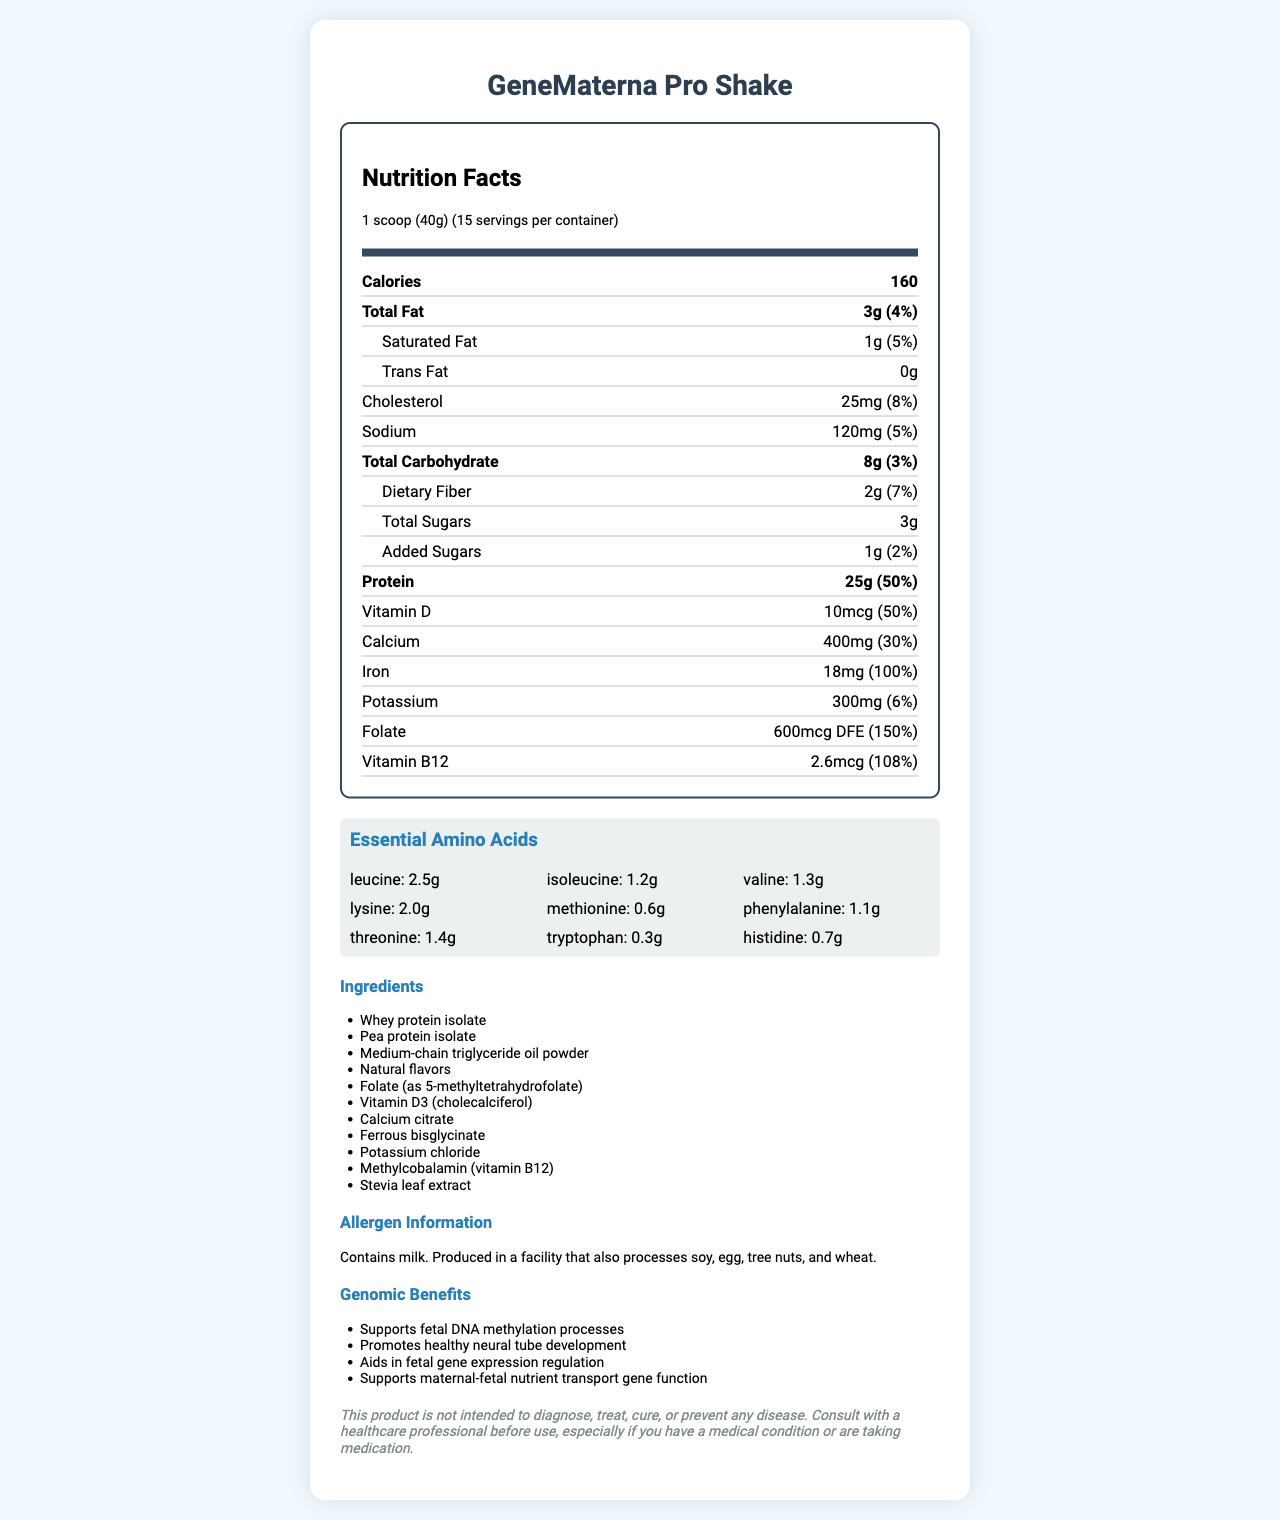what is the serving size of GeneMaterna Pro Shake? The serving size is clearly listed at the top of the Nutrition Facts section as "1 scoop (40g)".
Answer: 1 scoop (40g) how many grams of protein are in one serving? The protein content per serving is listed as "25g" in the Protein row.
Answer: 25g what is the daily percentage value of iron in one serving? The percentage daily value of iron is clearly stated as "100%" in the Iron row.
Answer: 100% which essential amino acid has the highest amount per serving? Leucine has the highest amount per serving listed as "2.5g" in the Essential Amino Acids section.
Answer: Leucine how many servings are there per container? The number of servings per container is listed at the top of the Nutrition Facts section as "15 servings per container".
Answer: 15 how much dietary fiber does one serving contain? A. 1g B. 2g C. 3g The dietary fiber amount per serving is listed as "2g" in the Total Carbohydrate section.
Answer: B which of the following ingredients is not listed in GeneMaterna Pro Shake? A. Whey protein isolate B. Medium-chain triglyceride oil powder C. Soy protein isolate Soy protein isolate is not listed in the ingredient list; Whey protein isolate and Medium-chain triglyceride oil powder are.
Answer: C which nutrient supports fetal DNA methylation processes? A. Folate B. Vitamin B12 C. Iron The genomic benefit of supporting fetal DNA methylation processes is specifically linked to folate.
Answer: A does GeneMaterna Pro Shake contain any allergens? The allergen information states: "Contains milk. Produced in a facility that also processes soy, egg, tree nuts, and wheat."
Answer: Yes summarize the main idea of this Nutrition Facts Label The document provides detailed nutrition information highlighting the protein content, essential amino acids, and critical vitamins and minerals for fetal development. It also mentions the product's genomic benefits and potential allergen information.
Answer: GeneMaterna Pro Shake is a protein shake designed for pregnant women. Each serving contains 160 calories, 25g of protein, and various vitamins and minerals essential for fetal development. It includes essential amino acids and ingredients like whey protein isolate and MCT oil. The product supports genomic benefits such as fetal DNA methylation and neural tube development. It contains milk and may contain traces of other allergens. what are the genomic benefits listed on the label? The genomic benefits section lists four specific benefits related to fetal development and maternal-fetal nutrient transport.
Answer: Supports fetal DNA methylation processes, Promotes healthy neural tube development, Aids in fetal gene expression regulation, Supports maternal-fetal nutrient transport gene function how many grams of sugar are in one serving of GeneMaterna Pro Shake? The Total Sugars row lists the amount of sugar per serving as "3g".
Answer: 3g can this product diagnose or cure diseases according to the disclaimer? The disclaimer clearly states: "This product is not intended to diagnose, treat, cure, or prevent any disease."
Answer: No what is the amount of folate in one serving? The folate amount per serving is listed as "600mcg DFE" in the vitamins section.
Answer: 600mcg DFE what flavor options are available for GeneMaterna Pro Shake? The document does not provide any information about flavor options, so it's impossible to determine available flavors from the provided information.
Answer: Cannot be determined 